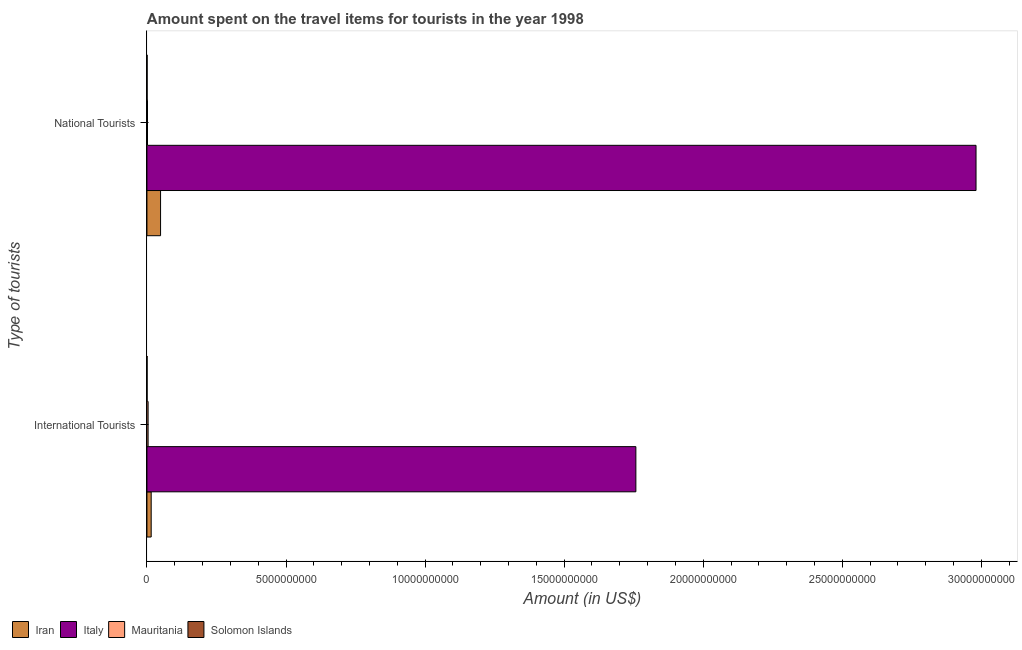How many different coloured bars are there?
Give a very brief answer. 4. How many groups of bars are there?
Ensure brevity in your answer.  2. Are the number of bars per tick equal to the number of legend labels?
Offer a terse response. Yes. How many bars are there on the 1st tick from the top?
Provide a short and direct response. 4. How many bars are there on the 1st tick from the bottom?
Ensure brevity in your answer.  4. What is the label of the 2nd group of bars from the top?
Provide a succinct answer. International Tourists. What is the amount spent on travel items of international tourists in Iran?
Your response must be concise. 1.53e+08. Across all countries, what is the maximum amount spent on travel items of national tourists?
Offer a very short reply. 2.98e+1. Across all countries, what is the minimum amount spent on travel items of international tourists?
Keep it short and to the point. 5.80e+06. In which country was the amount spent on travel items of international tourists minimum?
Offer a terse response. Solomon Islands. What is the total amount spent on travel items of international tourists in the graph?
Your response must be concise. 1.78e+1. What is the difference between the amount spent on travel items of national tourists in Solomon Islands and that in Italy?
Your answer should be compact. -2.98e+1. What is the difference between the amount spent on travel items of national tourists in Iran and the amount spent on travel items of international tourists in Solomon Islands?
Keep it short and to the point. 4.84e+08. What is the average amount spent on travel items of national tourists per country?
Offer a very short reply. 7.58e+09. What is the difference between the amount spent on travel items of international tourists and amount spent on travel items of national tourists in Mauritania?
Give a very brief answer. 2.20e+07. In how many countries, is the amount spent on travel items of national tourists greater than 26000000000 US$?
Make the answer very short. 1. What is the ratio of the amount spent on travel items of national tourists in Mauritania to that in Iran?
Provide a short and direct response. 0.04. Is the amount spent on travel items of international tourists in Solomon Islands less than that in Italy?
Offer a terse response. Yes. In how many countries, is the amount spent on travel items of international tourists greater than the average amount spent on travel items of international tourists taken over all countries?
Make the answer very short. 1. What does the 4th bar from the top in National Tourists represents?
Keep it short and to the point. Iran. What does the 1st bar from the bottom in National Tourists represents?
Your answer should be very brief. Iran. How many bars are there?
Your answer should be very brief. 8. How many countries are there in the graph?
Make the answer very short. 4. Are the values on the major ticks of X-axis written in scientific E-notation?
Provide a short and direct response. No. Where does the legend appear in the graph?
Ensure brevity in your answer.  Bottom left. How many legend labels are there?
Provide a short and direct response. 4. How are the legend labels stacked?
Offer a terse response. Horizontal. What is the title of the graph?
Your answer should be compact. Amount spent on the travel items for tourists in the year 1998. What is the label or title of the X-axis?
Give a very brief answer. Amount (in US$). What is the label or title of the Y-axis?
Provide a short and direct response. Type of tourists. What is the Amount (in US$) of Iran in International Tourists?
Give a very brief answer. 1.53e+08. What is the Amount (in US$) in Italy in International Tourists?
Keep it short and to the point. 1.76e+1. What is the Amount (in US$) in Mauritania in International Tourists?
Your answer should be compact. 4.20e+07. What is the Amount (in US$) in Solomon Islands in International Tourists?
Offer a very short reply. 5.80e+06. What is the Amount (in US$) in Iran in National Tourists?
Provide a succinct answer. 4.90e+08. What is the Amount (in US$) in Italy in National Tourists?
Give a very brief answer. 2.98e+1. What is the Amount (in US$) in Mauritania in National Tourists?
Your answer should be very brief. 2.00e+07. What is the Amount (in US$) in Solomon Islands in National Tourists?
Your answer should be very brief. 6.60e+06. Across all Type of tourists, what is the maximum Amount (in US$) of Iran?
Ensure brevity in your answer.  4.90e+08. Across all Type of tourists, what is the maximum Amount (in US$) of Italy?
Give a very brief answer. 2.98e+1. Across all Type of tourists, what is the maximum Amount (in US$) in Mauritania?
Ensure brevity in your answer.  4.20e+07. Across all Type of tourists, what is the maximum Amount (in US$) in Solomon Islands?
Give a very brief answer. 6.60e+06. Across all Type of tourists, what is the minimum Amount (in US$) of Iran?
Your answer should be compact. 1.53e+08. Across all Type of tourists, what is the minimum Amount (in US$) of Italy?
Your response must be concise. 1.76e+1. Across all Type of tourists, what is the minimum Amount (in US$) in Mauritania?
Provide a succinct answer. 2.00e+07. Across all Type of tourists, what is the minimum Amount (in US$) of Solomon Islands?
Keep it short and to the point. 5.80e+06. What is the total Amount (in US$) of Iran in the graph?
Your response must be concise. 6.43e+08. What is the total Amount (in US$) in Italy in the graph?
Make the answer very short. 4.74e+1. What is the total Amount (in US$) in Mauritania in the graph?
Your answer should be very brief. 6.20e+07. What is the total Amount (in US$) of Solomon Islands in the graph?
Your answer should be compact. 1.24e+07. What is the difference between the Amount (in US$) of Iran in International Tourists and that in National Tourists?
Provide a short and direct response. -3.37e+08. What is the difference between the Amount (in US$) in Italy in International Tourists and that in National Tourists?
Your response must be concise. -1.22e+1. What is the difference between the Amount (in US$) of Mauritania in International Tourists and that in National Tourists?
Keep it short and to the point. 2.20e+07. What is the difference between the Amount (in US$) of Solomon Islands in International Tourists and that in National Tourists?
Offer a very short reply. -8.00e+05. What is the difference between the Amount (in US$) in Iran in International Tourists and the Amount (in US$) in Italy in National Tourists?
Offer a terse response. -2.97e+1. What is the difference between the Amount (in US$) in Iran in International Tourists and the Amount (in US$) in Mauritania in National Tourists?
Provide a short and direct response. 1.33e+08. What is the difference between the Amount (in US$) of Iran in International Tourists and the Amount (in US$) of Solomon Islands in National Tourists?
Ensure brevity in your answer.  1.46e+08. What is the difference between the Amount (in US$) in Italy in International Tourists and the Amount (in US$) in Mauritania in National Tourists?
Keep it short and to the point. 1.76e+1. What is the difference between the Amount (in US$) in Italy in International Tourists and the Amount (in US$) in Solomon Islands in National Tourists?
Give a very brief answer. 1.76e+1. What is the difference between the Amount (in US$) of Mauritania in International Tourists and the Amount (in US$) of Solomon Islands in National Tourists?
Provide a succinct answer. 3.54e+07. What is the average Amount (in US$) of Iran per Type of tourists?
Your answer should be compact. 3.22e+08. What is the average Amount (in US$) of Italy per Type of tourists?
Make the answer very short. 2.37e+1. What is the average Amount (in US$) in Mauritania per Type of tourists?
Keep it short and to the point. 3.10e+07. What is the average Amount (in US$) of Solomon Islands per Type of tourists?
Your answer should be compact. 6.20e+06. What is the difference between the Amount (in US$) in Iran and Amount (in US$) in Italy in International Tourists?
Provide a succinct answer. -1.74e+1. What is the difference between the Amount (in US$) of Iran and Amount (in US$) of Mauritania in International Tourists?
Make the answer very short. 1.11e+08. What is the difference between the Amount (in US$) of Iran and Amount (in US$) of Solomon Islands in International Tourists?
Your response must be concise. 1.47e+08. What is the difference between the Amount (in US$) of Italy and Amount (in US$) of Mauritania in International Tourists?
Give a very brief answer. 1.75e+1. What is the difference between the Amount (in US$) of Italy and Amount (in US$) of Solomon Islands in International Tourists?
Ensure brevity in your answer.  1.76e+1. What is the difference between the Amount (in US$) in Mauritania and Amount (in US$) in Solomon Islands in International Tourists?
Your response must be concise. 3.62e+07. What is the difference between the Amount (in US$) in Iran and Amount (in US$) in Italy in National Tourists?
Offer a terse response. -2.93e+1. What is the difference between the Amount (in US$) of Iran and Amount (in US$) of Mauritania in National Tourists?
Your response must be concise. 4.70e+08. What is the difference between the Amount (in US$) in Iran and Amount (in US$) in Solomon Islands in National Tourists?
Provide a short and direct response. 4.83e+08. What is the difference between the Amount (in US$) of Italy and Amount (in US$) of Mauritania in National Tourists?
Give a very brief answer. 2.98e+1. What is the difference between the Amount (in US$) in Italy and Amount (in US$) in Solomon Islands in National Tourists?
Provide a short and direct response. 2.98e+1. What is the difference between the Amount (in US$) in Mauritania and Amount (in US$) in Solomon Islands in National Tourists?
Your answer should be very brief. 1.34e+07. What is the ratio of the Amount (in US$) in Iran in International Tourists to that in National Tourists?
Offer a very short reply. 0.31. What is the ratio of the Amount (in US$) in Italy in International Tourists to that in National Tourists?
Ensure brevity in your answer.  0.59. What is the ratio of the Amount (in US$) of Mauritania in International Tourists to that in National Tourists?
Provide a short and direct response. 2.1. What is the ratio of the Amount (in US$) in Solomon Islands in International Tourists to that in National Tourists?
Your answer should be compact. 0.88. What is the difference between the highest and the second highest Amount (in US$) of Iran?
Keep it short and to the point. 3.37e+08. What is the difference between the highest and the second highest Amount (in US$) in Italy?
Offer a terse response. 1.22e+1. What is the difference between the highest and the second highest Amount (in US$) in Mauritania?
Your answer should be very brief. 2.20e+07. What is the difference between the highest and the second highest Amount (in US$) of Solomon Islands?
Your answer should be very brief. 8.00e+05. What is the difference between the highest and the lowest Amount (in US$) in Iran?
Offer a terse response. 3.37e+08. What is the difference between the highest and the lowest Amount (in US$) in Italy?
Offer a terse response. 1.22e+1. What is the difference between the highest and the lowest Amount (in US$) in Mauritania?
Offer a terse response. 2.20e+07. 